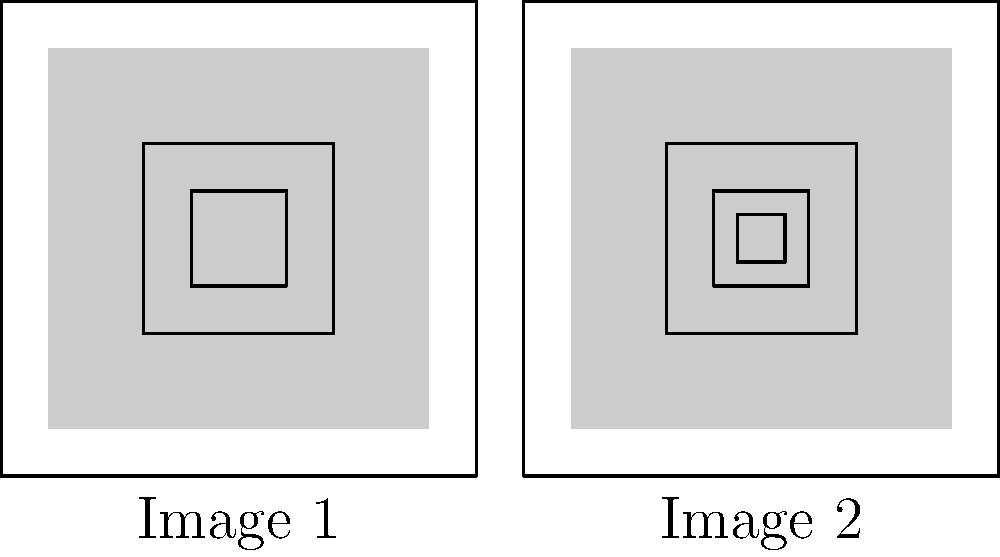As a journalist covering a developing story about architectural changes in a historic district, you've been given two similar images of a building facade. What is the key difference between Image 1 and Image 2 that could be significant for your report? To identify the key difference between the two images, let's analyze them step-by-step:

1. Overall structure: Both images show a square outline representing a building facade.
2. Background: Both have a light gray background filling most of the square.
3. Outer frame: Both have a larger square frame inside the main outline.
4. Inner frame: Both have a smaller square frame inside the larger one.
5. Central element: This is where the key difference lies.
   - Image 1 has only two squares in the center.
   - Image 2 has an additional small square in the very center.

The presence of this extra central square in Image 2 is the key difference. In architectural terms, this could represent:
- A new window or opening
- An added decorative element
- A structural modification

As a journalist, this subtle change could be significant for your report, potentially indicating:
- Ongoing renovation work
- Historical alterations to the building
- Differences between proposed plans and actual construction

This detail might be crucial for accurately reporting on changes in the historic district, especially if there are controversies or regulations surrounding modifications to historic structures.
Answer: Image 2 has an additional small square in the center, not present in Image 1. 